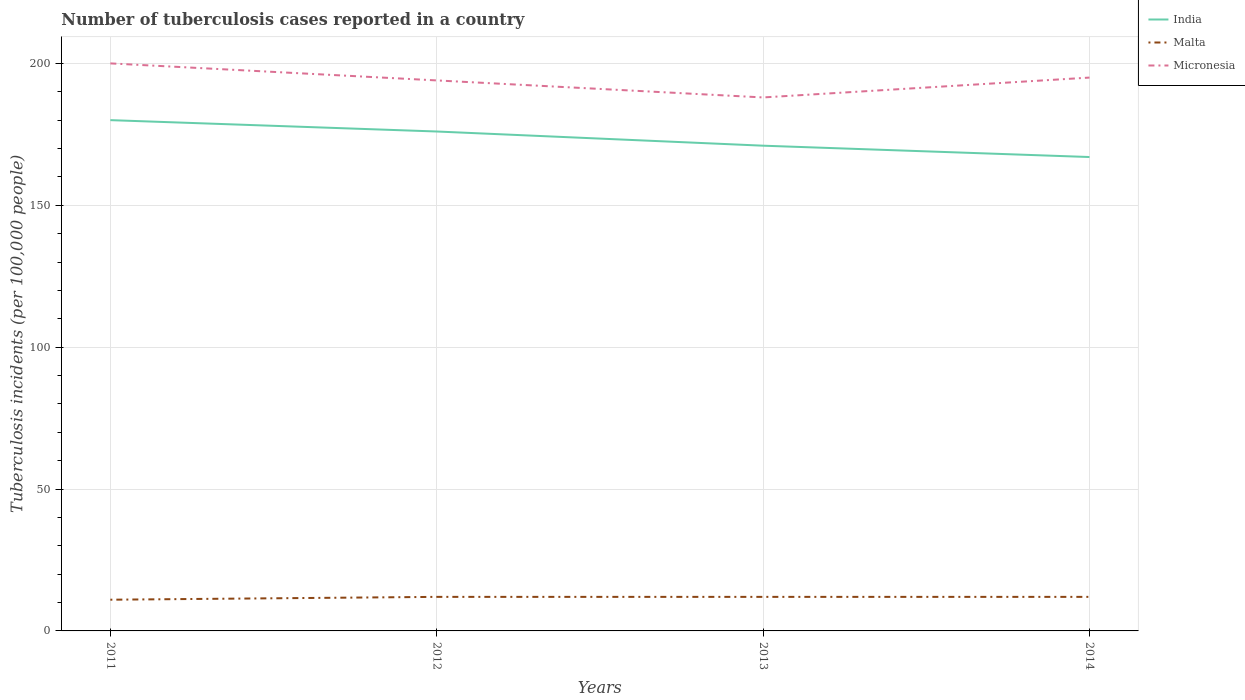How many different coloured lines are there?
Give a very brief answer. 3. Does the line corresponding to Malta intersect with the line corresponding to Micronesia?
Offer a terse response. No. Across all years, what is the maximum number of tuberculosis cases reported in in India?
Your answer should be compact. 167. What is the total number of tuberculosis cases reported in in Malta in the graph?
Your response must be concise. 0. What is the difference between the highest and the lowest number of tuberculosis cases reported in in India?
Make the answer very short. 2. What is the difference between two consecutive major ticks on the Y-axis?
Provide a short and direct response. 50. Are the values on the major ticks of Y-axis written in scientific E-notation?
Your response must be concise. No. Does the graph contain grids?
Your answer should be very brief. Yes. What is the title of the graph?
Give a very brief answer. Number of tuberculosis cases reported in a country. Does "Cayman Islands" appear as one of the legend labels in the graph?
Give a very brief answer. No. What is the label or title of the X-axis?
Keep it short and to the point. Years. What is the label or title of the Y-axis?
Ensure brevity in your answer.  Tuberculosis incidents (per 100,0 people). What is the Tuberculosis incidents (per 100,000 people) of India in 2011?
Your answer should be compact. 180. What is the Tuberculosis incidents (per 100,000 people) of Malta in 2011?
Provide a succinct answer. 11. What is the Tuberculosis incidents (per 100,000 people) in India in 2012?
Make the answer very short. 176. What is the Tuberculosis incidents (per 100,000 people) in Malta in 2012?
Your response must be concise. 12. What is the Tuberculosis incidents (per 100,000 people) in Micronesia in 2012?
Provide a succinct answer. 194. What is the Tuberculosis incidents (per 100,000 people) of India in 2013?
Keep it short and to the point. 171. What is the Tuberculosis incidents (per 100,000 people) of Malta in 2013?
Ensure brevity in your answer.  12. What is the Tuberculosis incidents (per 100,000 people) of Micronesia in 2013?
Provide a short and direct response. 188. What is the Tuberculosis incidents (per 100,000 people) of India in 2014?
Offer a terse response. 167. What is the Tuberculosis incidents (per 100,000 people) of Micronesia in 2014?
Offer a very short reply. 195. Across all years, what is the maximum Tuberculosis incidents (per 100,000 people) in India?
Keep it short and to the point. 180. Across all years, what is the maximum Tuberculosis incidents (per 100,000 people) of Micronesia?
Provide a short and direct response. 200. Across all years, what is the minimum Tuberculosis incidents (per 100,000 people) of India?
Offer a very short reply. 167. Across all years, what is the minimum Tuberculosis incidents (per 100,000 people) in Micronesia?
Ensure brevity in your answer.  188. What is the total Tuberculosis incidents (per 100,000 people) in India in the graph?
Your response must be concise. 694. What is the total Tuberculosis incidents (per 100,000 people) of Micronesia in the graph?
Offer a very short reply. 777. What is the difference between the Tuberculosis incidents (per 100,000 people) of India in 2011 and that in 2012?
Make the answer very short. 4. What is the difference between the Tuberculosis incidents (per 100,000 people) of Malta in 2011 and that in 2013?
Provide a succinct answer. -1. What is the difference between the Tuberculosis incidents (per 100,000 people) in Micronesia in 2011 and that in 2014?
Your answer should be compact. 5. What is the difference between the Tuberculosis incidents (per 100,000 people) in Micronesia in 2012 and that in 2013?
Your answer should be compact. 6. What is the difference between the Tuberculosis incidents (per 100,000 people) of Malta in 2012 and that in 2014?
Your answer should be very brief. 0. What is the difference between the Tuberculosis incidents (per 100,000 people) in India in 2013 and that in 2014?
Your answer should be compact. 4. What is the difference between the Tuberculosis incidents (per 100,000 people) of Malta in 2013 and that in 2014?
Offer a very short reply. 0. What is the difference between the Tuberculosis incidents (per 100,000 people) of India in 2011 and the Tuberculosis incidents (per 100,000 people) of Malta in 2012?
Give a very brief answer. 168. What is the difference between the Tuberculosis incidents (per 100,000 people) of Malta in 2011 and the Tuberculosis incidents (per 100,000 people) of Micronesia in 2012?
Your response must be concise. -183. What is the difference between the Tuberculosis incidents (per 100,000 people) in India in 2011 and the Tuberculosis incidents (per 100,000 people) in Malta in 2013?
Provide a succinct answer. 168. What is the difference between the Tuberculosis incidents (per 100,000 people) of Malta in 2011 and the Tuberculosis incidents (per 100,000 people) of Micronesia in 2013?
Provide a succinct answer. -177. What is the difference between the Tuberculosis incidents (per 100,000 people) of India in 2011 and the Tuberculosis incidents (per 100,000 people) of Malta in 2014?
Your answer should be very brief. 168. What is the difference between the Tuberculosis incidents (per 100,000 people) in India in 2011 and the Tuberculosis incidents (per 100,000 people) in Micronesia in 2014?
Provide a succinct answer. -15. What is the difference between the Tuberculosis incidents (per 100,000 people) of Malta in 2011 and the Tuberculosis incidents (per 100,000 people) of Micronesia in 2014?
Offer a terse response. -184. What is the difference between the Tuberculosis incidents (per 100,000 people) in India in 2012 and the Tuberculosis incidents (per 100,000 people) in Malta in 2013?
Keep it short and to the point. 164. What is the difference between the Tuberculosis incidents (per 100,000 people) in India in 2012 and the Tuberculosis incidents (per 100,000 people) in Micronesia in 2013?
Your response must be concise. -12. What is the difference between the Tuberculosis incidents (per 100,000 people) of Malta in 2012 and the Tuberculosis incidents (per 100,000 people) of Micronesia in 2013?
Offer a very short reply. -176. What is the difference between the Tuberculosis incidents (per 100,000 people) in India in 2012 and the Tuberculosis incidents (per 100,000 people) in Malta in 2014?
Offer a terse response. 164. What is the difference between the Tuberculosis incidents (per 100,000 people) of Malta in 2012 and the Tuberculosis incidents (per 100,000 people) of Micronesia in 2014?
Ensure brevity in your answer.  -183. What is the difference between the Tuberculosis incidents (per 100,000 people) of India in 2013 and the Tuberculosis incidents (per 100,000 people) of Malta in 2014?
Your answer should be compact. 159. What is the difference between the Tuberculosis incidents (per 100,000 people) of Malta in 2013 and the Tuberculosis incidents (per 100,000 people) of Micronesia in 2014?
Your response must be concise. -183. What is the average Tuberculosis incidents (per 100,000 people) in India per year?
Offer a very short reply. 173.5. What is the average Tuberculosis incidents (per 100,000 people) of Malta per year?
Make the answer very short. 11.75. What is the average Tuberculosis incidents (per 100,000 people) of Micronesia per year?
Give a very brief answer. 194.25. In the year 2011, what is the difference between the Tuberculosis incidents (per 100,000 people) of India and Tuberculosis incidents (per 100,000 people) of Malta?
Provide a succinct answer. 169. In the year 2011, what is the difference between the Tuberculosis incidents (per 100,000 people) in Malta and Tuberculosis incidents (per 100,000 people) in Micronesia?
Provide a short and direct response. -189. In the year 2012, what is the difference between the Tuberculosis incidents (per 100,000 people) in India and Tuberculosis incidents (per 100,000 people) in Malta?
Keep it short and to the point. 164. In the year 2012, what is the difference between the Tuberculosis incidents (per 100,000 people) of India and Tuberculosis incidents (per 100,000 people) of Micronesia?
Provide a succinct answer. -18. In the year 2012, what is the difference between the Tuberculosis incidents (per 100,000 people) in Malta and Tuberculosis incidents (per 100,000 people) in Micronesia?
Provide a short and direct response. -182. In the year 2013, what is the difference between the Tuberculosis incidents (per 100,000 people) of India and Tuberculosis incidents (per 100,000 people) of Malta?
Offer a very short reply. 159. In the year 2013, what is the difference between the Tuberculosis incidents (per 100,000 people) of India and Tuberculosis incidents (per 100,000 people) of Micronesia?
Ensure brevity in your answer.  -17. In the year 2013, what is the difference between the Tuberculosis incidents (per 100,000 people) of Malta and Tuberculosis incidents (per 100,000 people) of Micronesia?
Your answer should be very brief. -176. In the year 2014, what is the difference between the Tuberculosis incidents (per 100,000 people) of India and Tuberculosis incidents (per 100,000 people) of Malta?
Your answer should be very brief. 155. In the year 2014, what is the difference between the Tuberculosis incidents (per 100,000 people) in Malta and Tuberculosis incidents (per 100,000 people) in Micronesia?
Your answer should be very brief. -183. What is the ratio of the Tuberculosis incidents (per 100,000 people) in India in 2011 to that in 2012?
Your answer should be very brief. 1.02. What is the ratio of the Tuberculosis incidents (per 100,000 people) of Micronesia in 2011 to that in 2012?
Keep it short and to the point. 1.03. What is the ratio of the Tuberculosis incidents (per 100,000 people) in India in 2011 to that in 2013?
Your answer should be compact. 1.05. What is the ratio of the Tuberculosis incidents (per 100,000 people) in Malta in 2011 to that in 2013?
Offer a terse response. 0.92. What is the ratio of the Tuberculosis incidents (per 100,000 people) of Micronesia in 2011 to that in 2013?
Offer a terse response. 1.06. What is the ratio of the Tuberculosis incidents (per 100,000 people) in India in 2011 to that in 2014?
Provide a succinct answer. 1.08. What is the ratio of the Tuberculosis incidents (per 100,000 people) of Malta in 2011 to that in 2014?
Ensure brevity in your answer.  0.92. What is the ratio of the Tuberculosis incidents (per 100,000 people) of Micronesia in 2011 to that in 2014?
Make the answer very short. 1.03. What is the ratio of the Tuberculosis incidents (per 100,000 people) in India in 2012 to that in 2013?
Offer a very short reply. 1.03. What is the ratio of the Tuberculosis incidents (per 100,000 people) of Malta in 2012 to that in 2013?
Offer a terse response. 1. What is the ratio of the Tuberculosis incidents (per 100,000 people) in Micronesia in 2012 to that in 2013?
Provide a succinct answer. 1.03. What is the ratio of the Tuberculosis incidents (per 100,000 people) of India in 2012 to that in 2014?
Offer a very short reply. 1.05. What is the ratio of the Tuberculosis incidents (per 100,000 people) of Malta in 2012 to that in 2014?
Provide a short and direct response. 1. What is the ratio of the Tuberculosis incidents (per 100,000 people) of Malta in 2013 to that in 2014?
Your answer should be compact. 1. What is the ratio of the Tuberculosis incidents (per 100,000 people) in Micronesia in 2013 to that in 2014?
Your response must be concise. 0.96. What is the difference between the highest and the second highest Tuberculosis incidents (per 100,000 people) in India?
Your answer should be very brief. 4. What is the difference between the highest and the second highest Tuberculosis incidents (per 100,000 people) in Malta?
Provide a succinct answer. 0. What is the difference between the highest and the second highest Tuberculosis incidents (per 100,000 people) of Micronesia?
Your answer should be very brief. 5. 